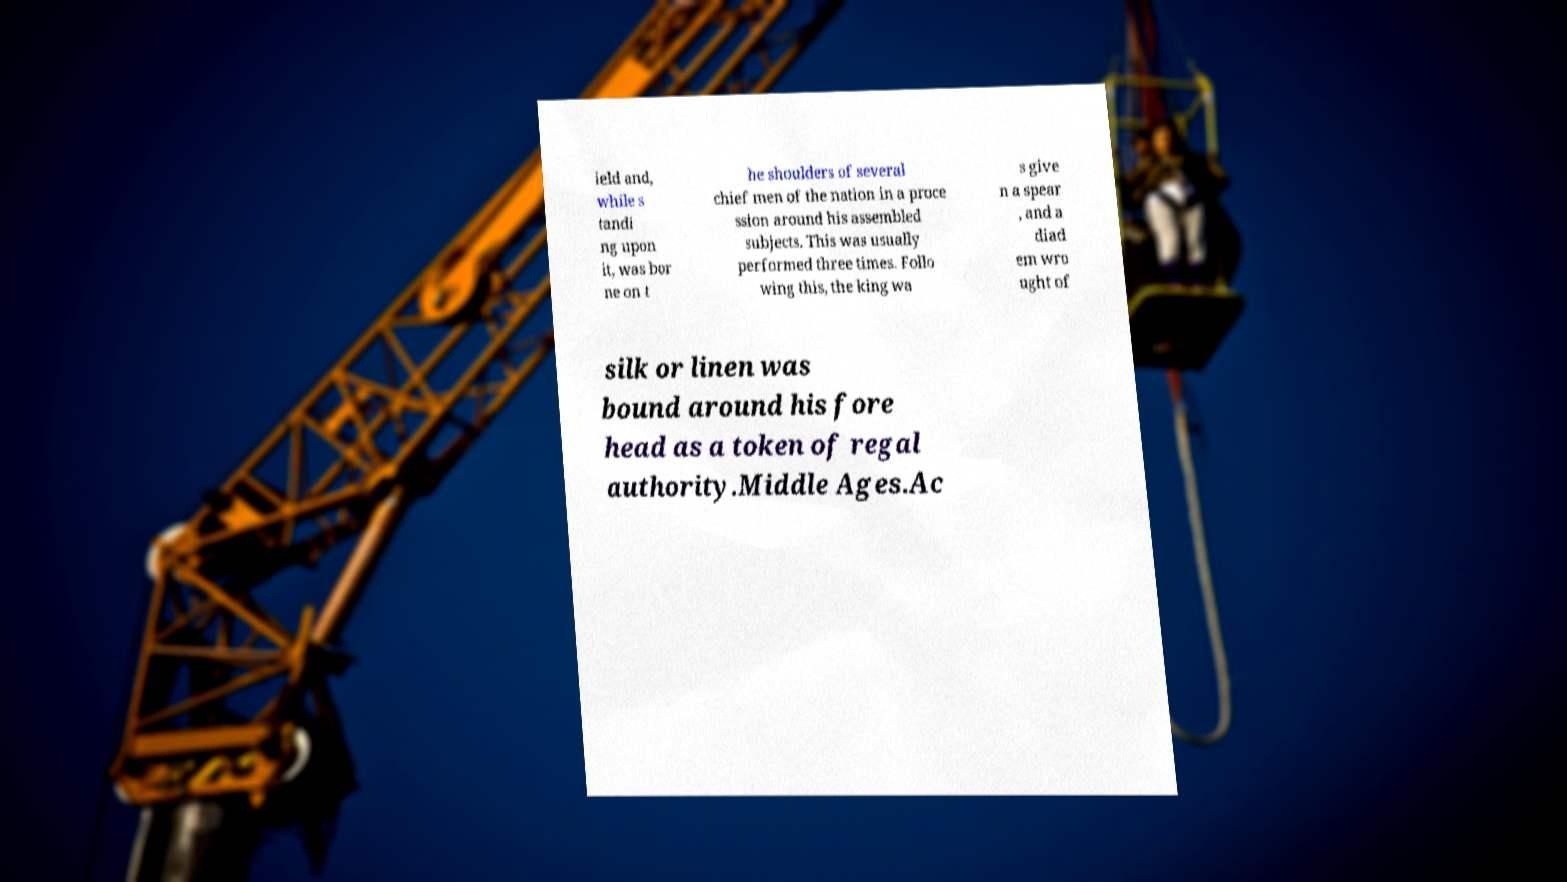Can you read and provide the text displayed in the image?This photo seems to have some interesting text. Can you extract and type it out for me? ield and, while s tandi ng upon it, was bor ne on t he shoulders of several chief men of the nation in a proce ssion around his assembled subjects. This was usually performed three times. Follo wing this, the king wa s give n a spear , and a diad em wro ught of silk or linen was bound around his fore head as a token of regal authority.Middle Ages.Ac 